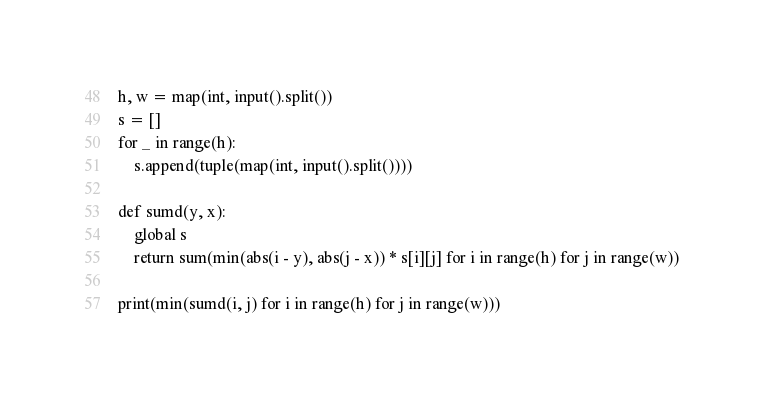<code> <loc_0><loc_0><loc_500><loc_500><_Python_>h, w = map(int, input().split())
s = []
for _ in range(h):
    s.append(tuple(map(int, input().split())))

def sumd(y, x):
    global s
    return sum(min(abs(i - y), abs(j - x)) * s[i][j] for i in range(h) for j in range(w))

print(min(sumd(i, j) for i in range(h) for j in range(w)))
</code> 